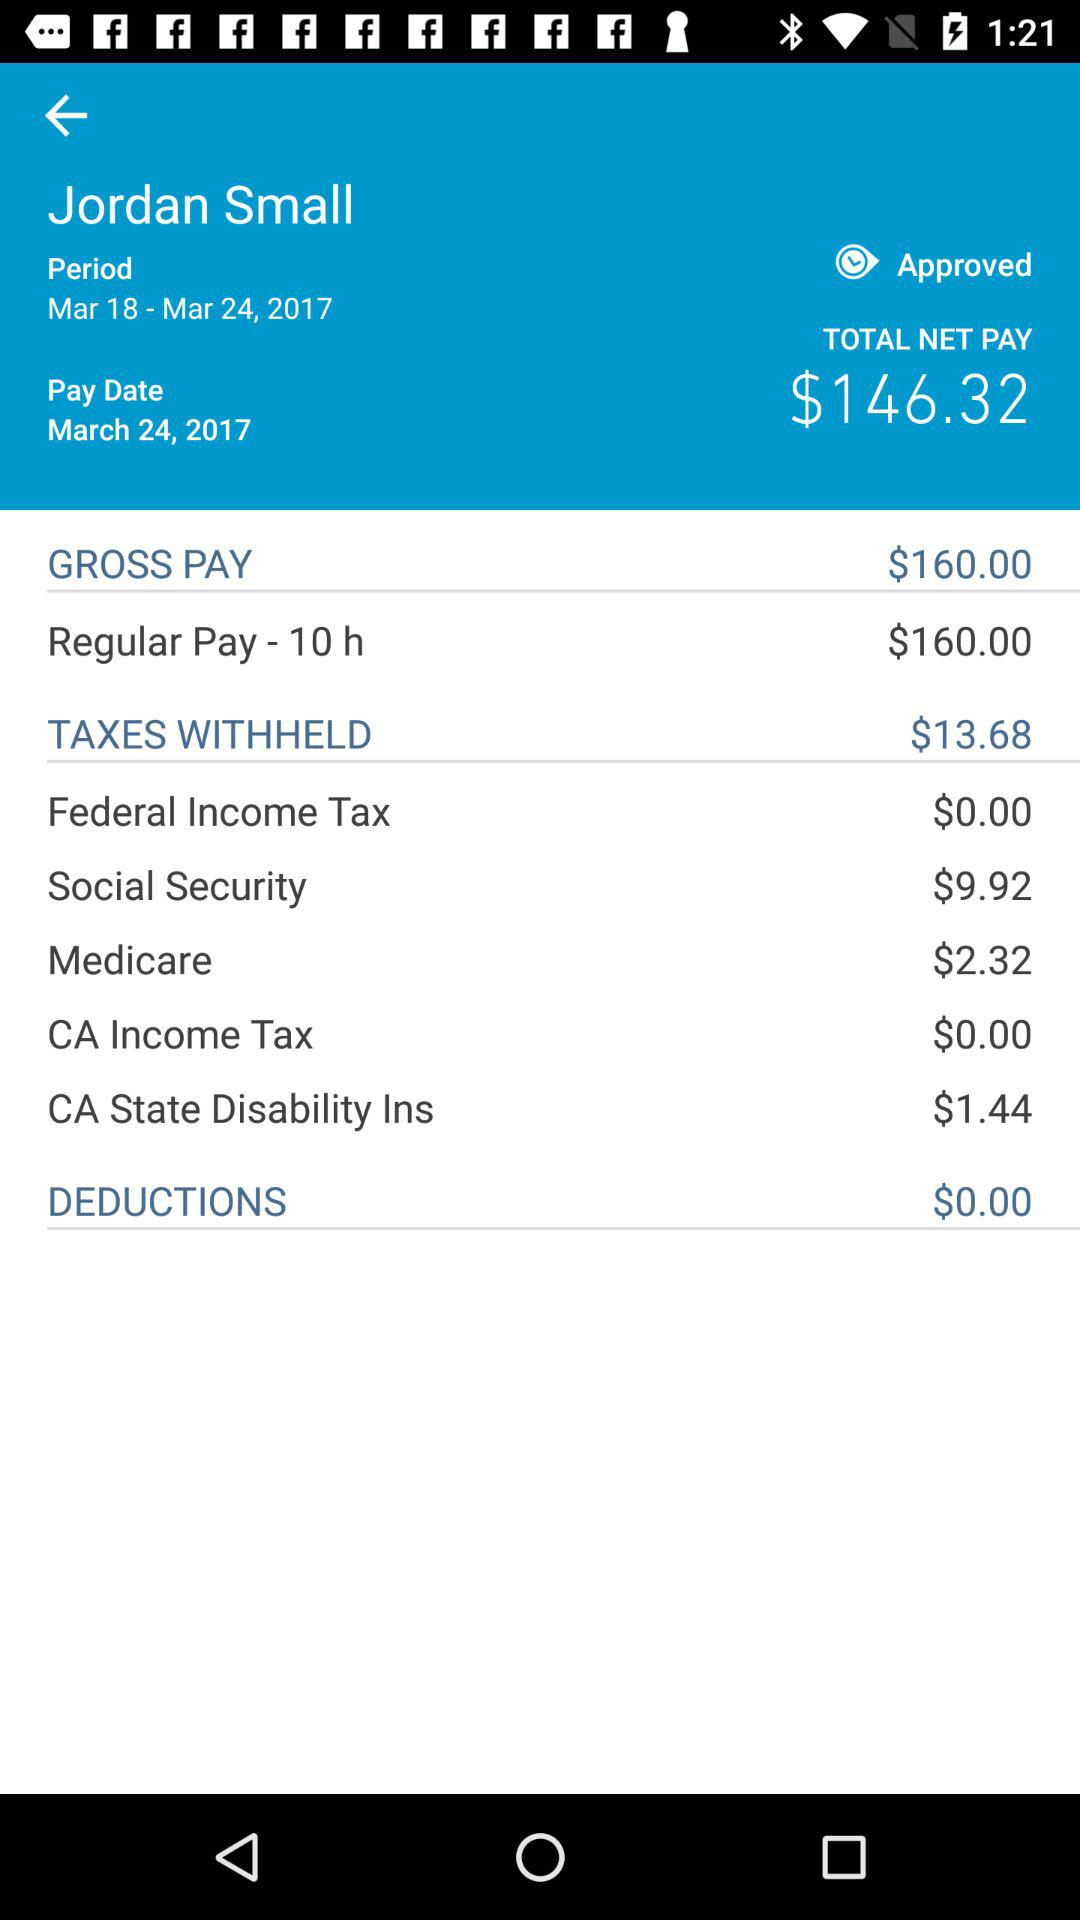What is the amount of gross pay in dollars? The amount of gross pay is $160. 